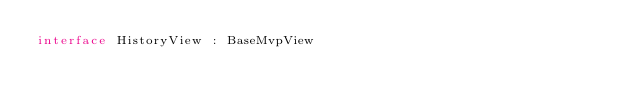Convert code to text. <code><loc_0><loc_0><loc_500><loc_500><_Kotlin_>interface HistoryView : BaseMvpView
</code> 